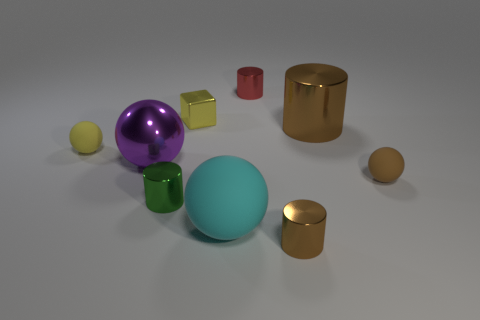Imagine these objects were part of a game, how might it be played? If these objects were part of a game, we could imagine a scenario where each object serves a different purpose or value, akin to a 3D board game. Players might be required to collect or arrange the objects based on specific rules—for instance, accumulating objects of a certain material or color. The various sizes could represent different point values, and the shiny objects might be 'bonus' pieces that offer additional points or special gameplay advantages. The objective could revolve around strategy, spatial thinking, and perhaps even physical dexterity if players must carefully move the objects without disturbing the arrangement. 